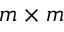<formula> <loc_0><loc_0><loc_500><loc_500>m \times m</formula> 